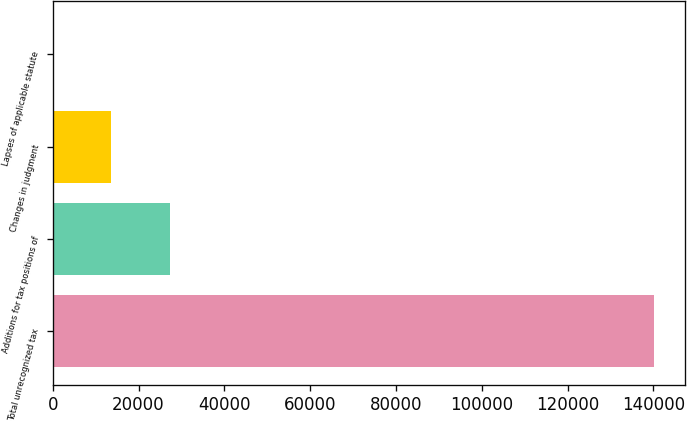<chart> <loc_0><loc_0><loc_500><loc_500><bar_chart><fcel>Total unrecognized tax<fcel>Additions for tax positions of<fcel>Changes in judgment<fcel>Lapses of applicable statute<nl><fcel>140269<fcel>27252.8<fcel>13681.4<fcel>110<nl></chart> 